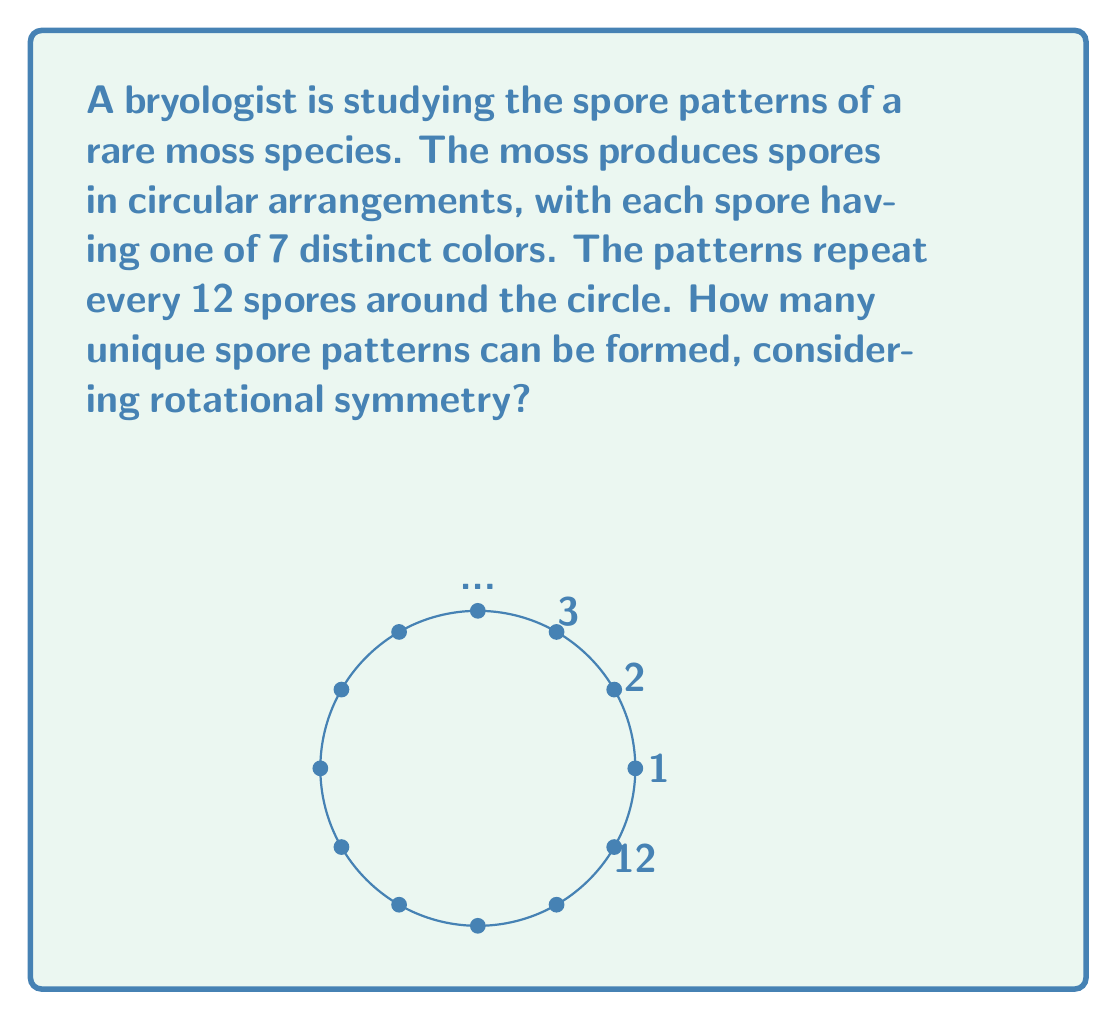Give your solution to this math problem. Let's approach this step-by-step using modular arithmetic and Ring theory concepts:

1) First, we need to understand that this is a problem of circular permutations with repetition allowed.

2) The total number of possible arrangements without considering rotational symmetry would be $7^{12}$, as we have 7 choices for each of the 12 positions.

3) However, due to rotational symmetry, many of these arrangements are equivalent. We need to divide our total by the number of rotations that produce distinct arrangements.

4) In modular arithmetic, we can represent this as working in $\mathbb{Z}_{12}$, the ring of integers modulo 12.

5) The number of distinct rotations is given by the order of the cyclic group generated by 1 in $\mathbb{Z}_{12}$, which is 12.

6) Therefore, we need to divide our total by 12 to account for these symmetries.

7) However, we're not done yet. Some patterns may have additional symmetries. For example, a pattern that repeats every 3 spores will only have 4 distinct rotations, not 12.

8) To account for this, we need to use Burnside's lemma from Group theory.

9) Let $G$ be the group of rotations (isomorphic to $\mathbb{Z}_{12}$), and $X$ be the set of all colorings. Burnside's lemma states:

   $$ |X/G| = \frac{1}{|G|} \sum_{g \in G} |X^g| $$

   where $|X/G|$ is the number of orbits (unique patterns), and $|X^g|$ is the number of colorings fixed by rotation $g$.

10) For a rotation by $k$ positions, a coloring is fixed if it repeats every $\gcd(k,12)$ positions. So $|X^g| = 7^{\gcd(k,12)}$.

11) Applying Burnside's lemma:

    $$ |X/G| = \frac{1}{12} (7^{12} + 7^6 + 7^4 + 7^3 + 7^2 + 7^1 + 7^6 + 7^3 + 7^4 + 7^1 + 7^2 + 7^1) $$

12) Simplifying:

    $$ |X/G| = \frac{1}{12} (7^{12} + 2\cdot7^6 + 2\cdot7^4 + 2\cdot7^3 + 2\cdot7^2 + 3\cdot7^1) $$

This gives us the number of unique spore patterns.
Answer: $\frac{1}{12} (7^{12} + 2\cdot7^6 + 2\cdot7^4 + 2\cdot7^3 + 2\cdot7^2 + 3\cdot7^1)$ 